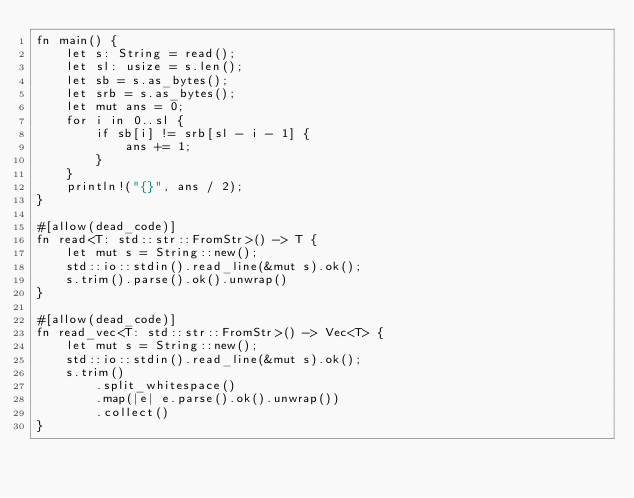Convert code to text. <code><loc_0><loc_0><loc_500><loc_500><_Rust_>fn main() {
    let s: String = read();
    let sl: usize = s.len();
    let sb = s.as_bytes();
    let srb = s.as_bytes();
    let mut ans = 0;
    for i in 0..sl {
        if sb[i] != srb[sl - i - 1] {
            ans += 1;
        }
    }
    println!("{}", ans / 2);
}

#[allow(dead_code)]
fn read<T: std::str::FromStr>() -> T {
    let mut s = String::new();
    std::io::stdin().read_line(&mut s).ok();
    s.trim().parse().ok().unwrap()
}

#[allow(dead_code)]
fn read_vec<T: std::str::FromStr>() -> Vec<T> {
    let mut s = String::new();
    std::io::stdin().read_line(&mut s).ok();
    s.trim()
        .split_whitespace()
        .map(|e| e.parse().ok().unwrap())
        .collect()
}
</code> 